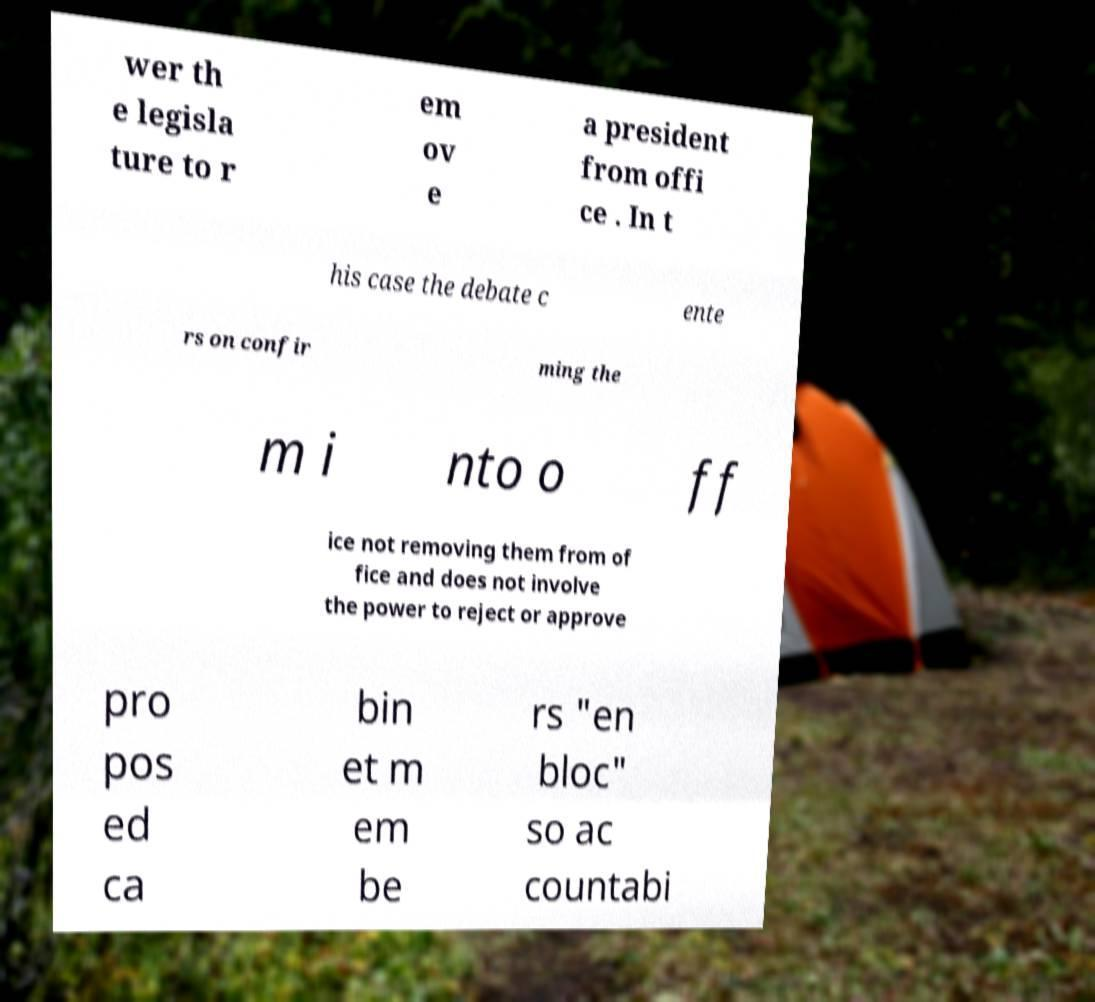Please identify and transcribe the text found in this image. wer th e legisla ture to r em ov e a president from offi ce . In t his case the debate c ente rs on confir ming the m i nto o ff ice not removing them from of fice and does not involve the power to reject or approve pro pos ed ca bin et m em be rs "en bloc" so ac countabi 